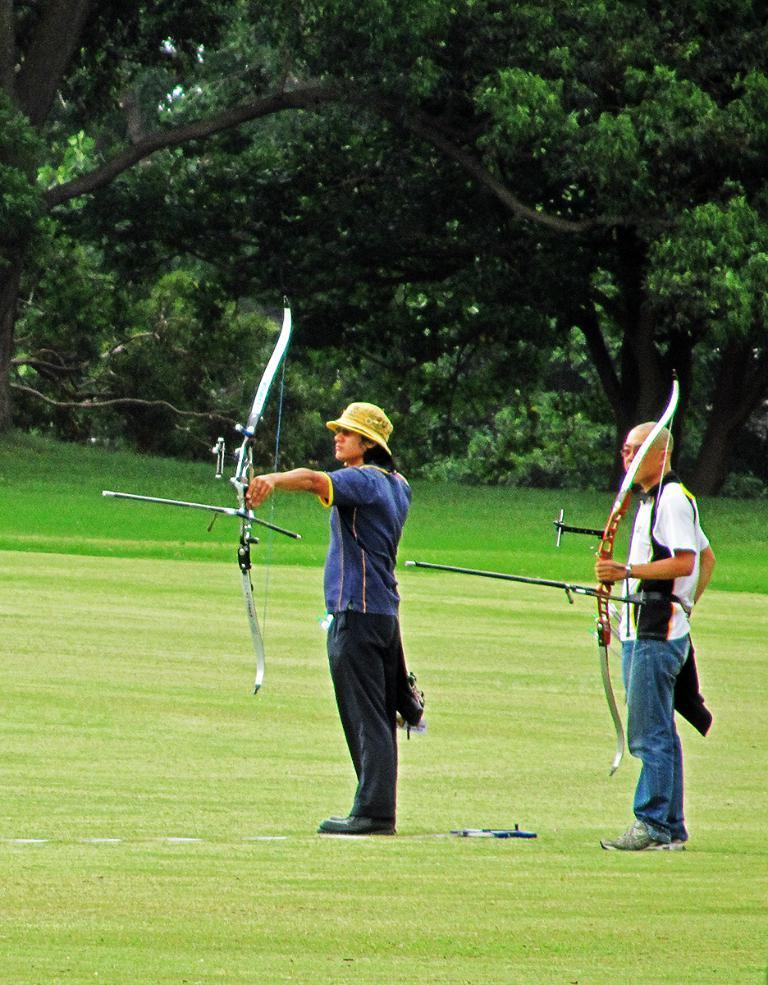How many people are in the image? There are two persons in the center of the image. What are the persons holding in their hands? The persons are holding bows in their hands. What type of terrain is visible at the bottom of the image? There is grass at the bottom of the image. What can be seen in the background of the image? There are trees in the background of the image. What type of clover is growing in the image? There is no clover visible in the image; it only features grass and trees. What is the starting point for the persons in the image? The provided facts do not mention a starting point for the persons; they are simply holding bows in their hands. 